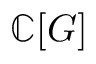<formula> <loc_0><loc_0><loc_500><loc_500>\mathbb { C } [ G ]</formula> 